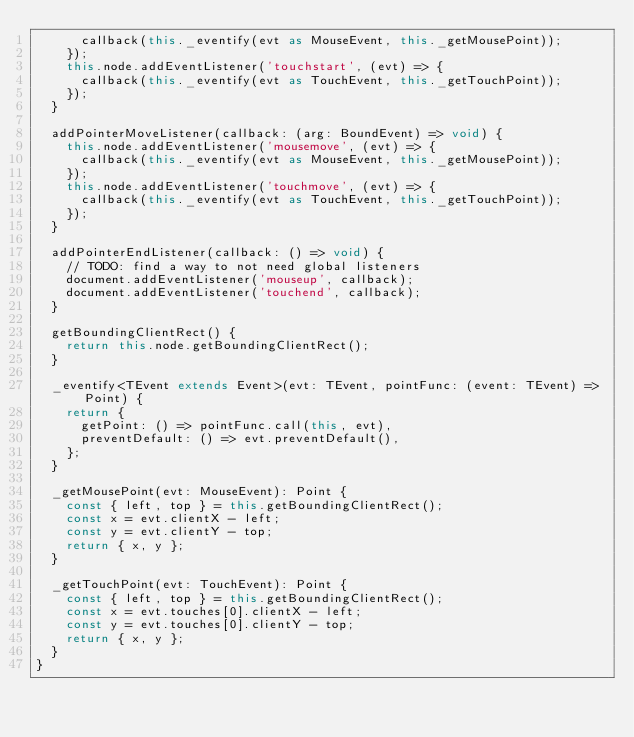Convert code to text. <code><loc_0><loc_0><loc_500><loc_500><_TypeScript_>      callback(this._eventify(evt as MouseEvent, this._getMousePoint));
    });
    this.node.addEventListener('touchstart', (evt) => {
      callback(this._eventify(evt as TouchEvent, this._getTouchPoint));
    });
  }

  addPointerMoveListener(callback: (arg: BoundEvent) => void) {
    this.node.addEventListener('mousemove', (evt) => {
      callback(this._eventify(evt as MouseEvent, this._getMousePoint));
    });
    this.node.addEventListener('touchmove', (evt) => {
      callback(this._eventify(evt as TouchEvent, this._getTouchPoint));
    });
  }

  addPointerEndListener(callback: () => void) {
    // TODO: find a way to not need global listeners
    document.addEventListener('mouseup', callback);
    document.addEventListener('touchend', callback);
  }

  getBoundingClientRect() {
    return this.node.getBoundingClientRect();
  }

  _eventify<TEvent extends Event>(evt: TEvent, pointFunc: (event: TEvent) => Point) {
    return {
      getPoint: () => pointFunc.call(this, evt),
      preventDefault: () => evt.preventDefault(),
    };
  }

  _getMousePoint(evt: MouseEvent): Point {
    const { left, top } = this.getBoundingClientRect();
    const x = evt.clientX - left;
    const y = evt.clientY - top;
    return { x, y };
  }

  _getTouchPoint(evt: TouchEvent): Point {
    const { left, top } = this.getBoundingClientRect();
    const x = evt.touches[0].clientX - left;
    const y = evt.touches[0].clientY - top;
    return { x, y };
  }
}
</code> 